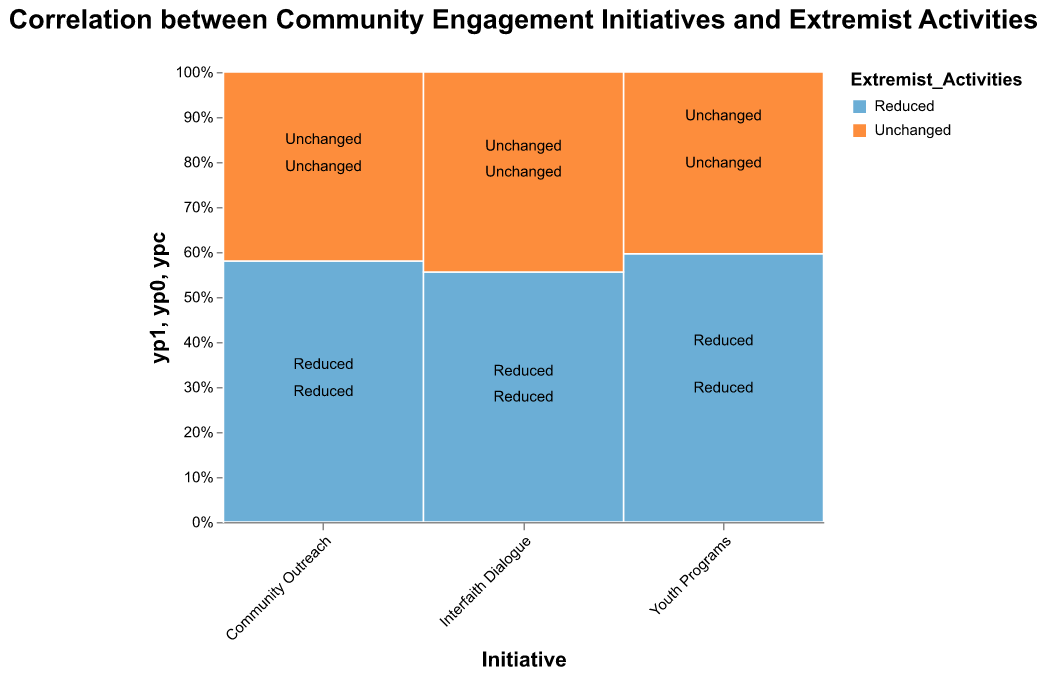Which area has the highest number of "Reduced" extremist activities for Youth Programs? The figure shows that "Urban" has a higher proportion of the orange segment (representing "Reduced" extremist activities) in the Youth Programs initiative compared to the "Rural" area. Specifically, the count is 178 for Urban and 87 for Rural.
Answer: Urban What is the overall trend for the "Youth Programs" initiative in terms of extremist activities? For both Urban and Rural areas, the "Youth Programs" initiative shows a higher proportion of "Reduced" extremist activities (178 in Urban and 87 in Rural) compared to "Unchanged" activities (43 in Urban and 59 in Rural).
Answer: Reduced Which initiative in Rural areas shows the smallest difference between "Reduced" and "Unchanged" extremist activities? In Rural areas, "Interfaith Dialogue" shows the smallest difference between "Reduced" (65) and "Unchanged" (52) activities, a difference of 13.
Answer: Interfaith Dialogue Between Urban and Rural areas, which has a larger proportion of "Unchanged" extremist activities for "Community Outreach"? Urban has a smaller proportion of "Unchanged" extremist activities (62) for "Community Outreach" compared to Rural (71), even though the total counts are such. Hence, Rural has a larger proportion for this initiative.
Answer: Rural How do the proportions of "Reduced" and "Unchanged" extremist activities compare between Urban and Rural areas for "Interfaith Dialogue"? In Urban areas, "Interfaith Dialogue" has a higher proportion of "Reduced" (112) compared to "Unchanged" (55) extremist activities. In Rural areas, the numbers are closer (65 "Reduced" and 52 "Unchanged"), showing a smaller difference.
Answer: Urban has a more effective reduction Which area and initiative show the highest number of "Unchanged" extremist activities? In the figure, the highest number of "Unchanged" extremist activities is seen in the Rural area for the "Community Outreach" initiative with a count of 71.
Answer: Rural, Community Outreach For Urban areas, which initiative shows the most significant reduction in extremist activities? In Urban areas, "Youth Programs" has the highest number of reduced extremist activities at 178. This is greater than the counts for "Community Outreach" (145) and "Interfaith Dialogue" (112).
Answer: Youth Programs Compare the effectiveness of the "Interfaith Dialogue" initiative between Urban and Rural areas in reducing extremist activities. The "Interfaith Dialogue" initiative appears more effective in Urban areas (112 reduced) compared to Rural areas (65 reduced). The difference in effectiveness can be inferred from the counts and corresponding mosaic plot segments.
Answer: Urban Which initiative in Urban areas has the highest proportion of "Unchanged" extremist activities and what is the implication? Urban areas show that "Community Outreach" has the highest count of "Unchanged" extremist activities (62). This implies that while it still contributes to reducing activities (145), it is less effective compared to other initiatives.
Answer: Community Outreach 